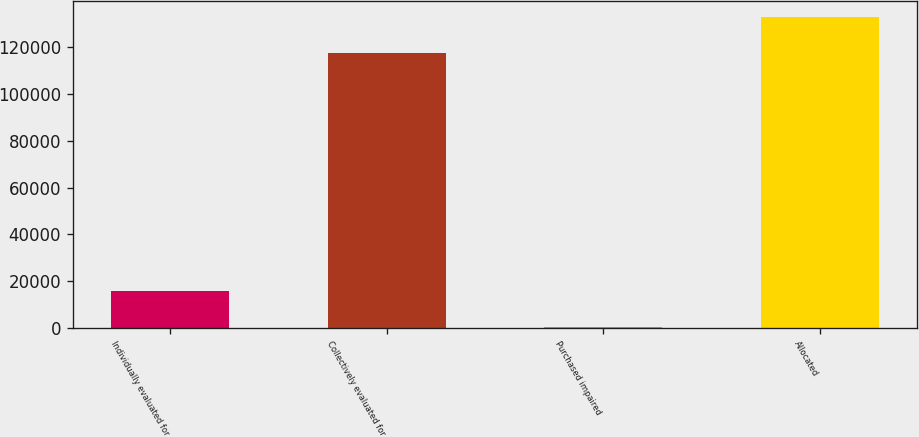<chart> <loc_0><loc_0><loc_500><loc_500><bar_chart><fcel>Individually evaluated for<fcel>Collectively evaluated for<fcel>Purchased impaired<fcel>Allocated<nl><fcel>15492<fcel>117475<fcel>100<fcel>133067<nl></chart> 